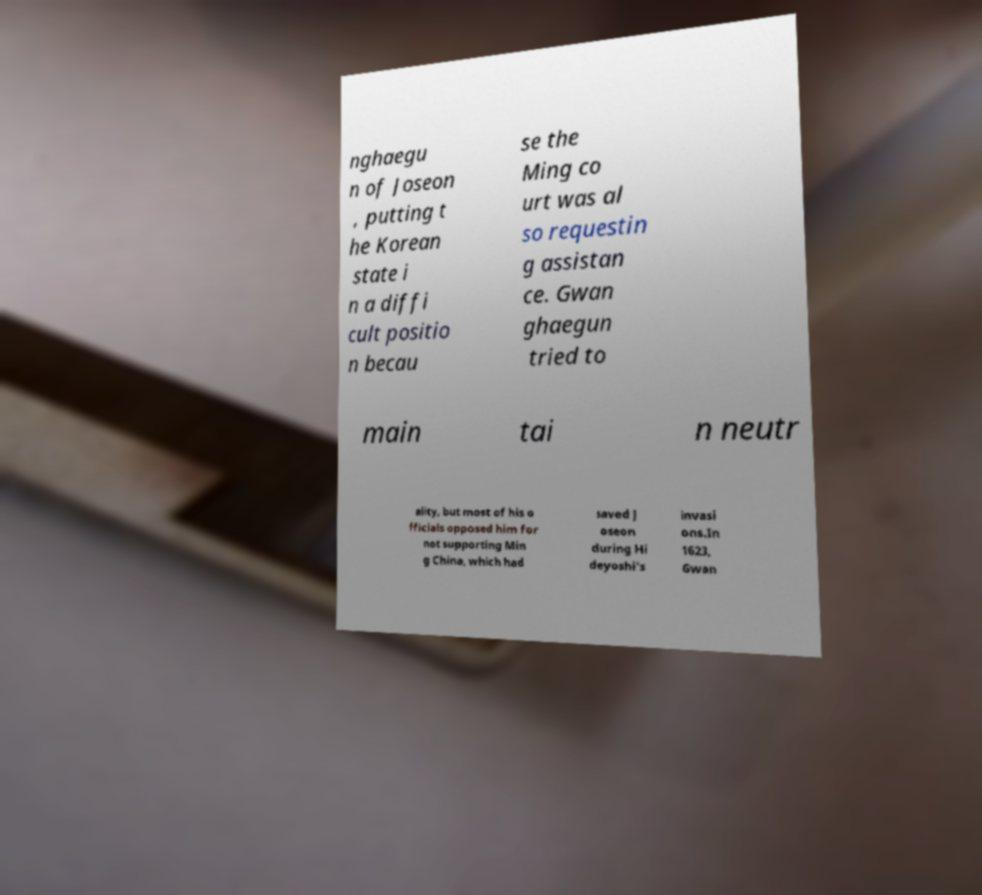For documentation purposes, I need the text within this image transcribed. Could you provide that? nghaegu n of Joseon , putting t he Korean state i n a diffi cult positio n becau se the Ming co urt was al so requestin g assistan ce. Gwan ghaegun tried to main tai n neutr ality, but most of his o fficials opposed him for not supporting Min g China, which had saved J oseon during Hi deyoshi's invasi ons.In 1623, Gwan 